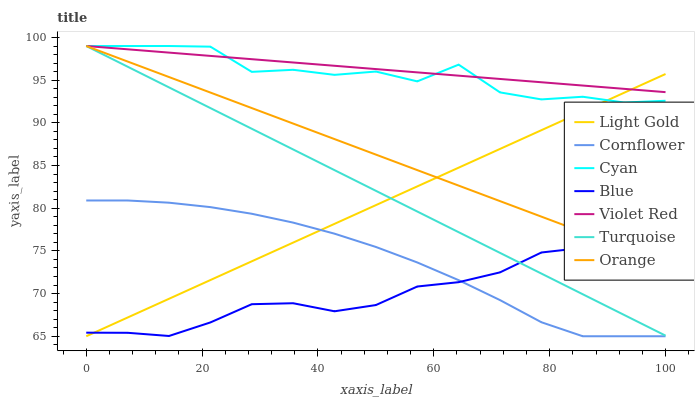Does Cornflower have the minimum area under the curve?
Answer yes or no. No. Does Cornflower have the maximum area under the curve?
Answer yes or no. No. Is Cornflower the smoothest?
Answer yes or no. No. Is Cornflower the roughest?
Answer yes or no. No. Does Violet Red have the lowest value?
Answer yes or no. No. Does Cornflower have the highest value?
Answer yes or no. No. Is Blue less than Cyan?
Answer yes or no. Yes. Is Cyan greater than Cornflower?
Answer yes or no. Yes. Does Blue intersect Cyan?
Answer yes or no. No. 